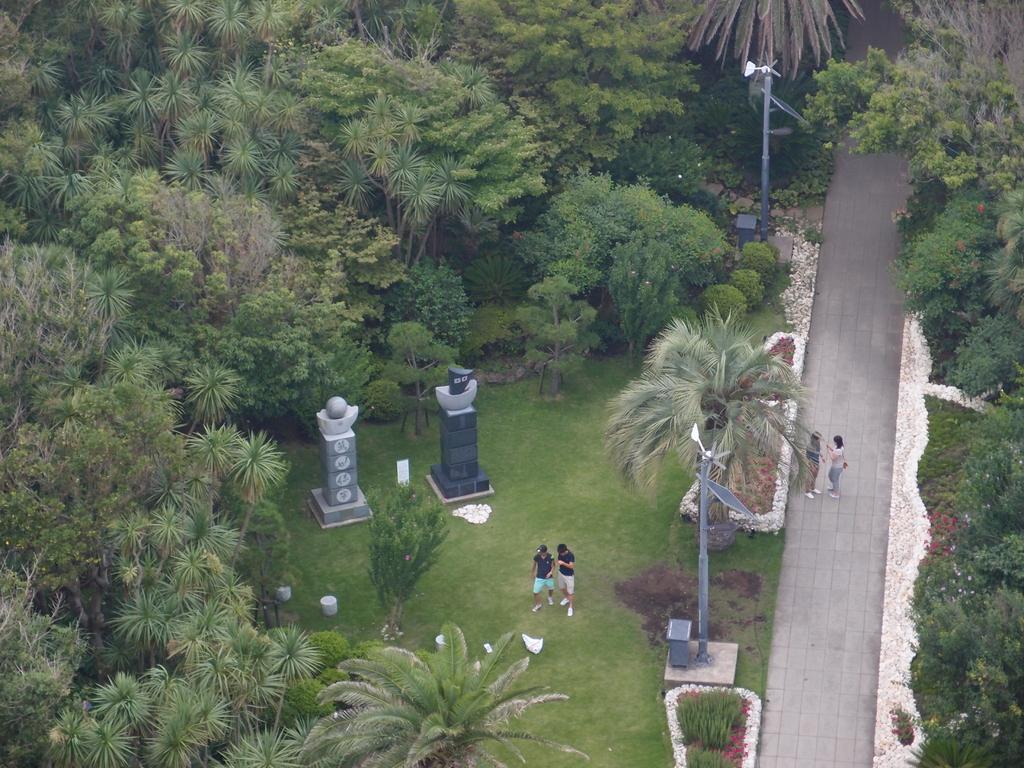In one or two sentences, can you explain what this image depicts? In the image we can see some trees, poles, plants, grass and four persons are standing. 